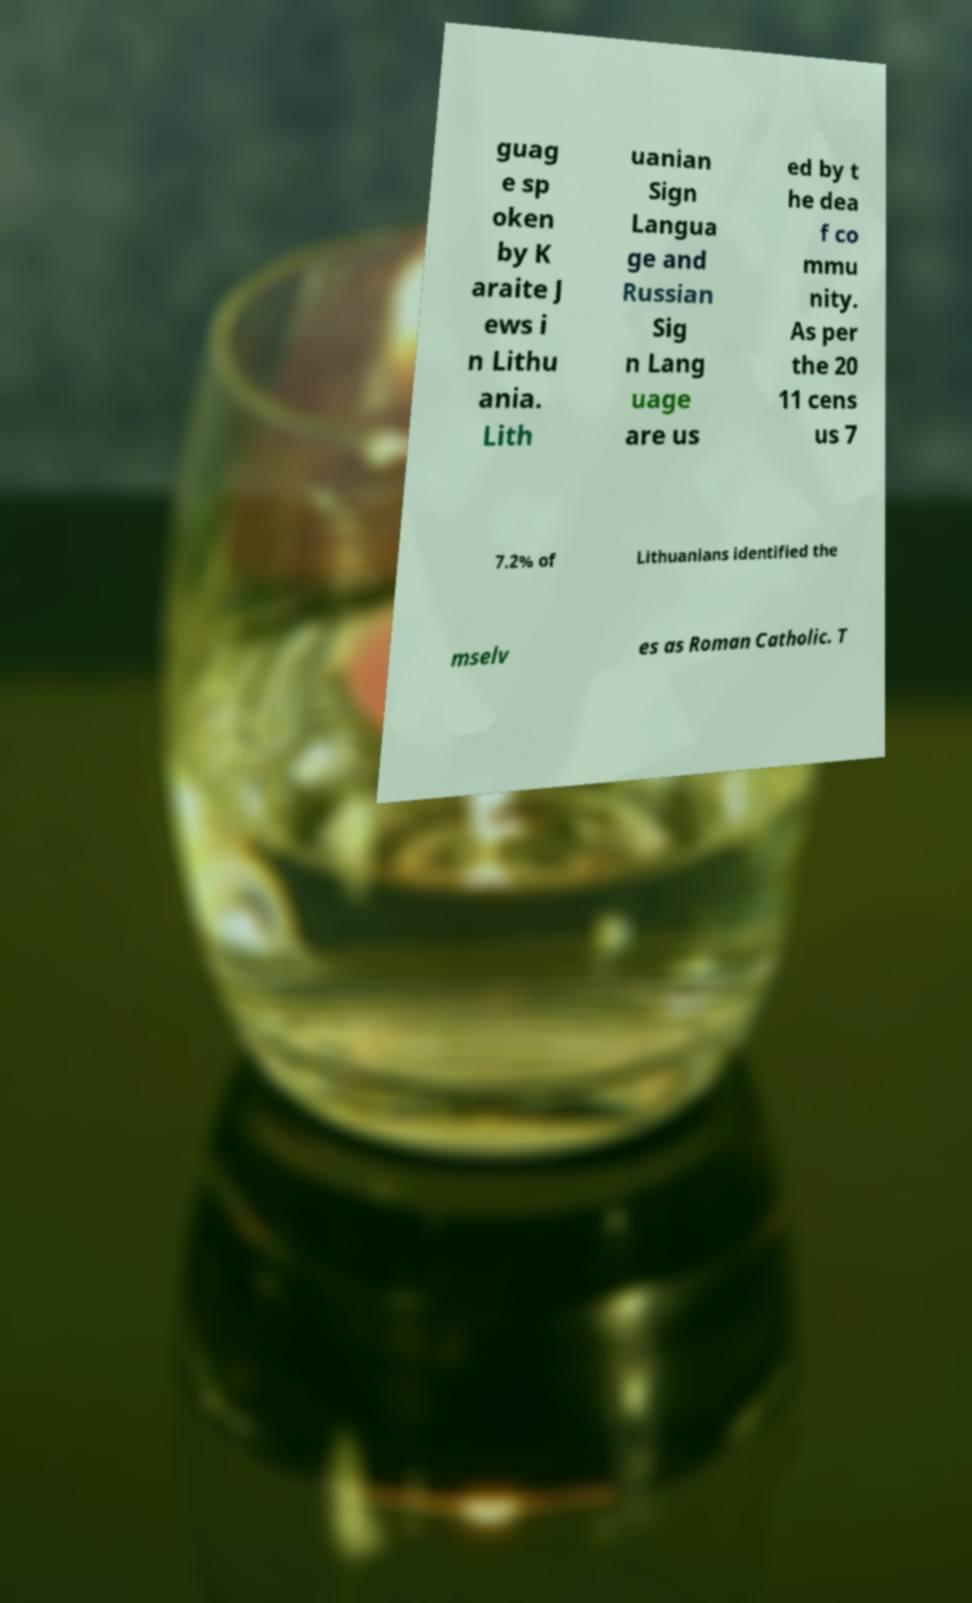Could you assist in decoding the text presented in this image and type it out clearly? guag e sp oken by K araite J ews i n Lithu ania. Lith uanian Sign Langua ge and Russian Sig n Lang uage are us ed by t he dea f co mmu nity. As per the 20 11 cens us 7 7.2% of Lithuanians identified the mselv es as Roman Catholic. T 